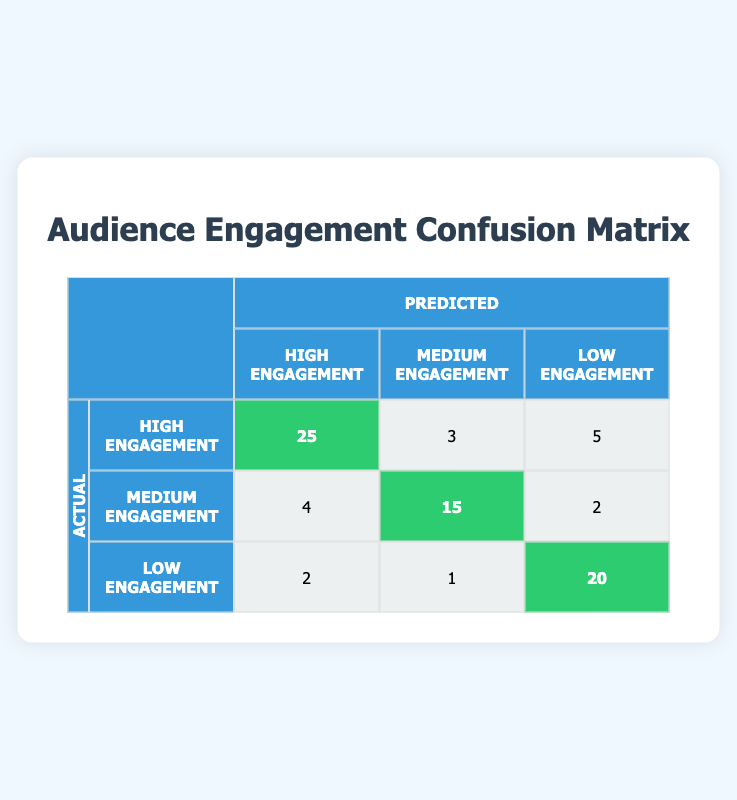What is the count of instances where high engagement was correctly predicted? In the confusion matrix, the count of correctly predicted high engagement is found on the diagonal in the cell corresponding to actual high engagement and predicted high engagement. This value is 25.
Answer: 25 What is the total number of instances categorized as medium engagement? To obtain the total count for medium engagement, we sum the values located in the medium engagement row: 15 (correctly predicted) + 4 (predicted as high) + 2 (predicted as low) = 21.
Answer: 21 Is it true that the predicted low engagement instances are greater than the predicted medium engagement instances? The total predicted low engagement instances can be calculated as follows: 20 (correctly predicted) + 2 (predicted as high) + 1 (predicted as medium) = 23. The total predicted medium engagement instances are 15 (correctly predicted) + 4 (predicted as high) + 2 (predicted as low) = 21. Since 23 > 21, the statement is true.
Answer: Yes How many instances were predicted as low engagement when the actual engagement was high? Referring to the confusion matrix, the number of instances where high engagement was misclassified as low engagement is the value located in the high engagement row, low engagement column, which is 5.
Answer: 5 If we consider all instances of low engagement, what percentage was correctly predicted? First, we need to count the total instances of low engagement, which is 20 (correctly predicted as low) + 2 (predicted as high) + 1 (predicted as medium) = 23. Next, we consider the count of correctly predicted low engagement instances, which is 20. The percentage is then (20/23) * 100 = 86.96%.
Answer: 86.96% What is the difference between the number of actual high engagement instances and the predicted medium engagement instances? The total number of actual high engagement instances is obtained by adding those correctly identified and those misclassified: 25 (correctly predicted) + 3 (predicted as medium) + 5 (predicted as low) = 33. The predicted medium engagement instances are 15 from the confusion matrix. The difference is 33 - 15 = 18.
Answer: 18 What is the total number of predicted high engagement instances? To find the total predicted high engagement instances, we add the counts from the high engagement column: 25 (correctly predicted) + 4 (predicted as medium) + 2 (predicted as low) = 31.
Answer: 31 What is the ratio of correctly predicted medium engagement instances to total medium engagement instances? The correctly predicted medium engagement instances are 15. Total instances for medium engagement are 21, as calculated before. The ratio is 15/21, which simplifies to approximately 0.7143.
Answer: 0.7143 